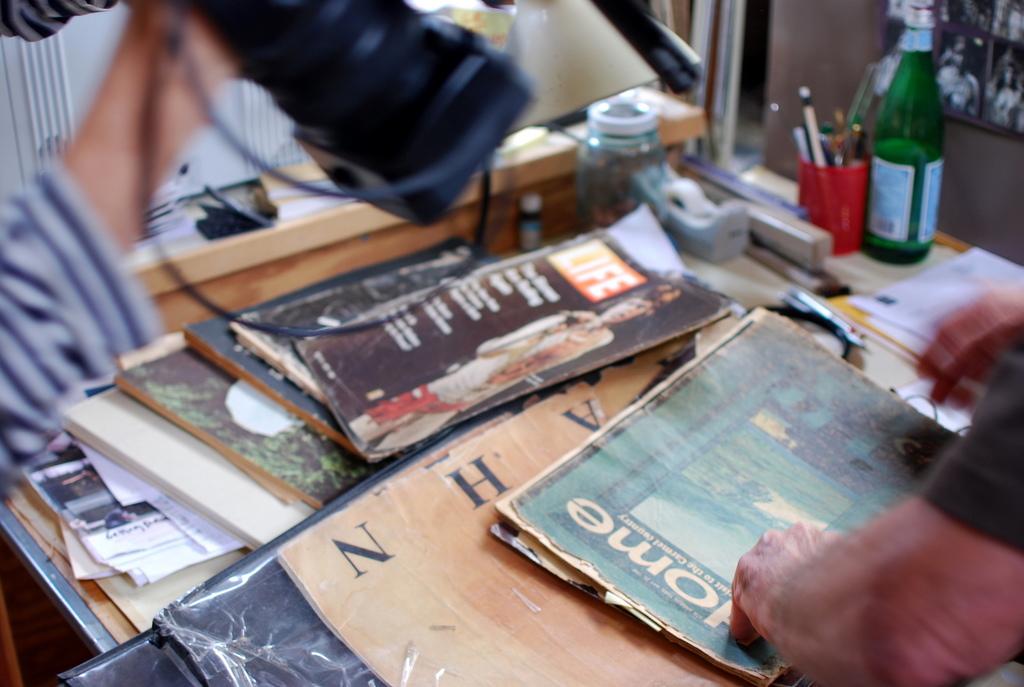What are the titles of these magazines?
Give a very brief answer. Home. 